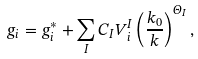Convert formula to latex. <formula><loc_0><loc_0><loc_500><loc_500>g _ { i } = g _ { i } ^ { \ast } + \sum _ { I } C _ { I } V _ { i } ^ { I } \left ( \frac { k _ { 0 } } { k } \right ) ^ { \Theta _ { I } } ,</formula> 